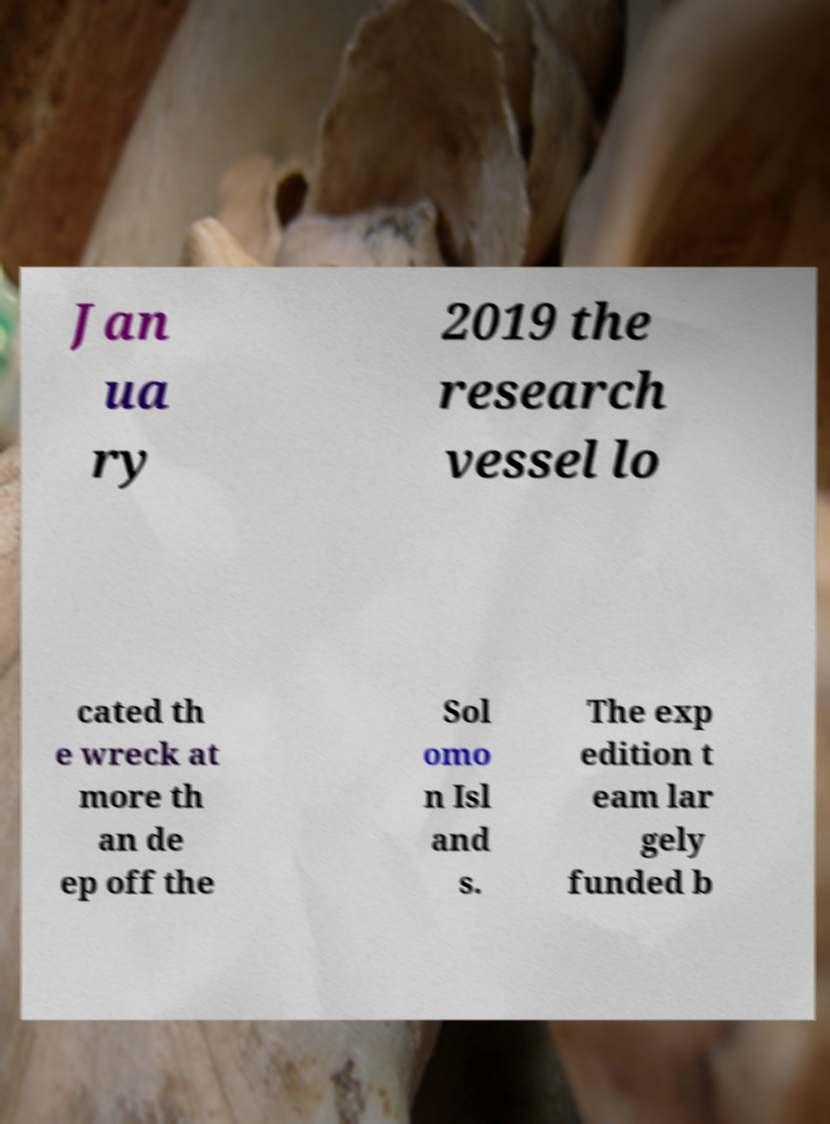Please identify and transcribe the text found in this image. Jan ua ry 2019 the research vessel lo cated th e wreck at more th an de ep off the Sol omo n Isl and s. The exp edition t eam lar gely funded b 